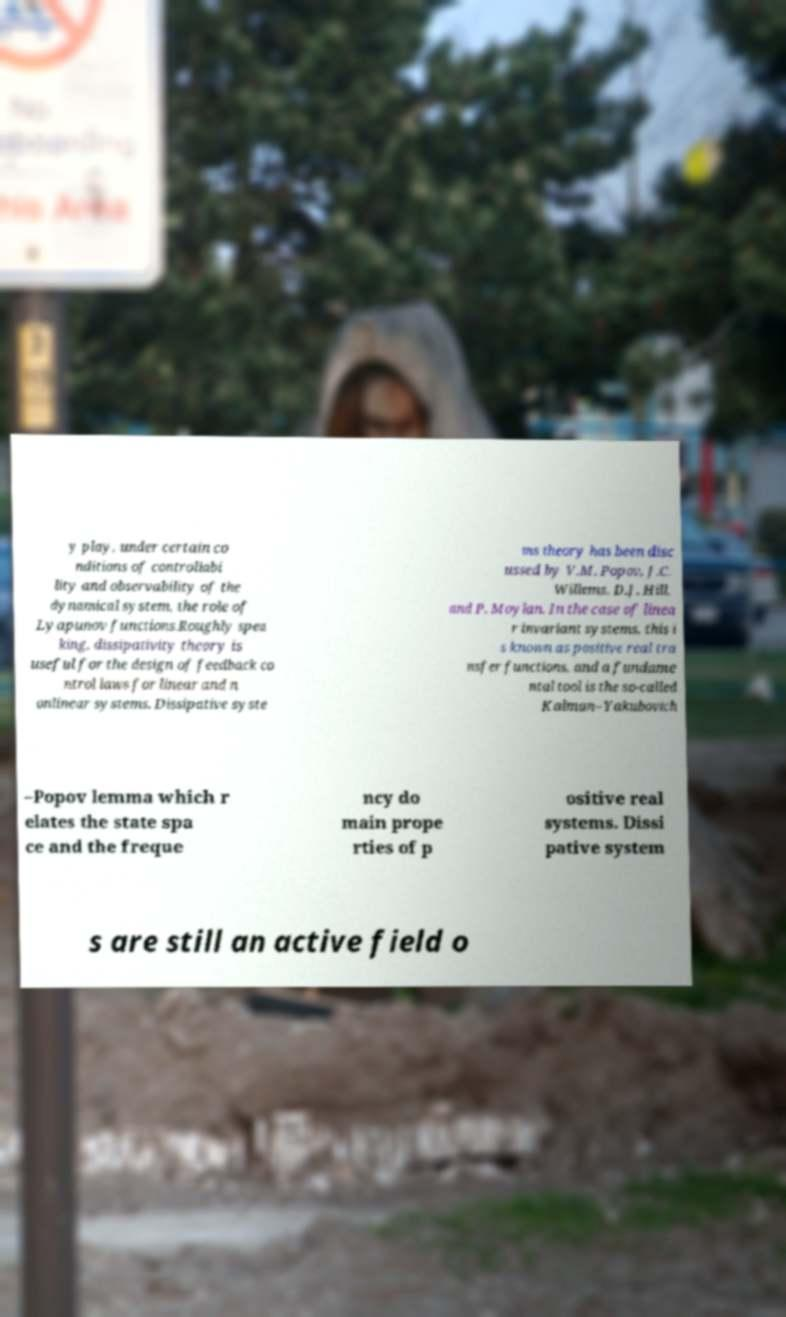I need the written content from this picture converted into text. Can you do that? y play, under certain co nditions of controllabi lity and observability of the dynamical system, the role of Lyapunov functions.Roughly spea king, dissipativity theory is useful for the design of feedback co ntrol laws for linear and n onlinear systems. Dissipative syste ms theory has been disc ussed by V.M. Popov, J.C. Willems, D.J. Hill, and P. Moylan. In the case of linea r invariant systems, this i s known as positive real tra nsfer functions, and a fundame ntal tool is the so-called Kalman–Yakubovich –Popov lemma which r elates the state spa ce and the freque ncy do main prope rties of p ositive real systems. Dissi pative system s are still an active field o 